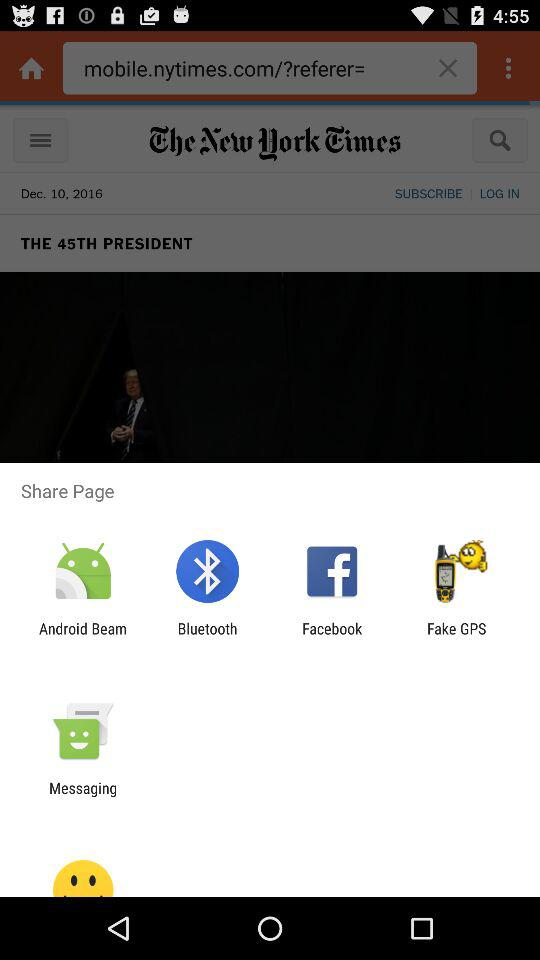What is the newspaper name? The newspaper name is "The New York Times". 